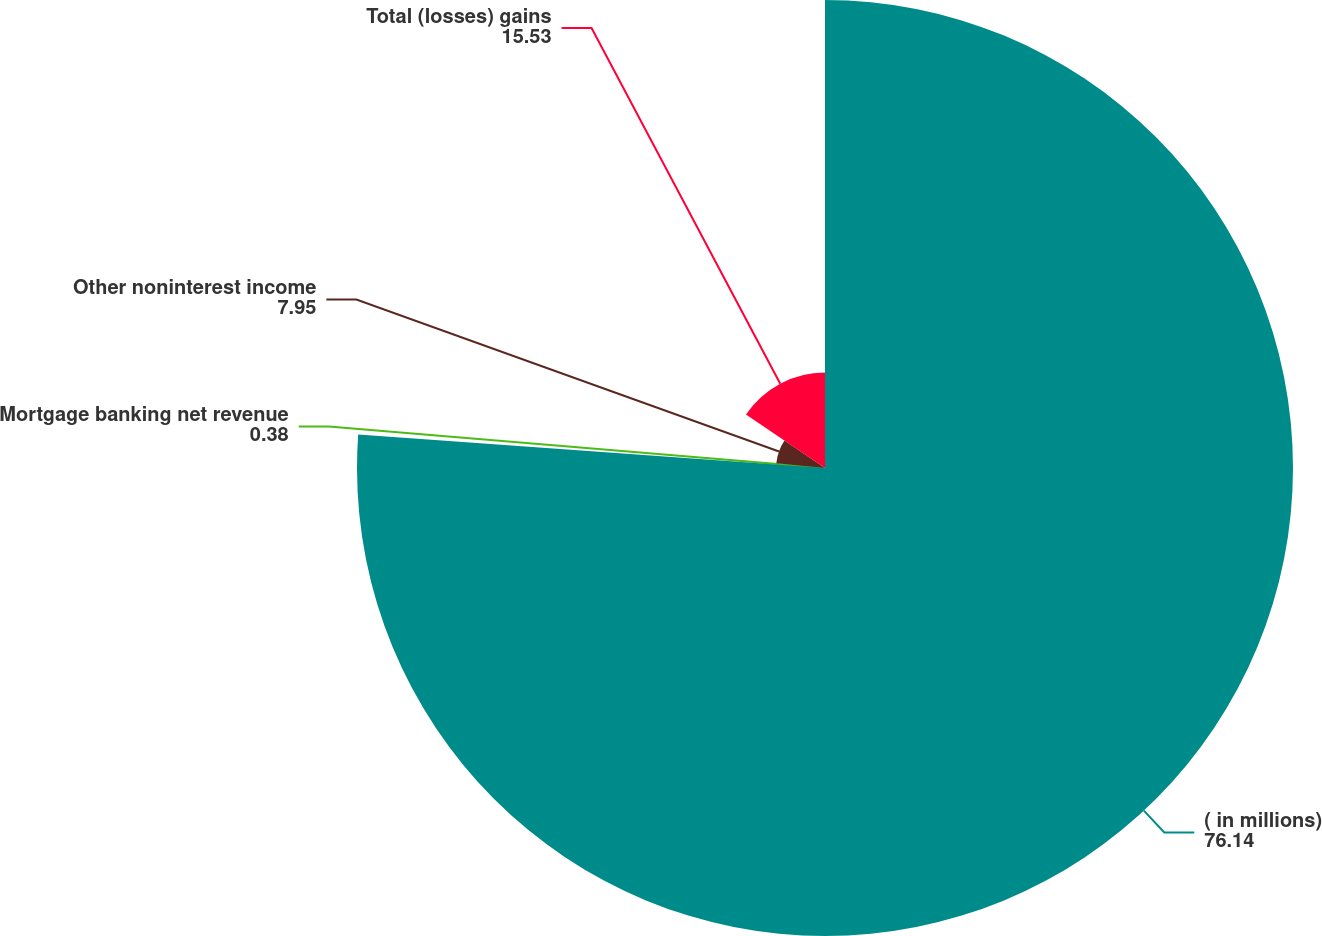Convert chart to OTSL. <chart><loc_0><loc_0><loc_500><loc_500><pie_chart><fcel>( in millions)<fcel>Mortgage banking net revenue<fcel>Other noninterest income<fcel>Total (losses) gains<nl><fcel>76.14%<fcel>0.38%<fcel>7.95%<fcel>15.53%<nl></chart> 